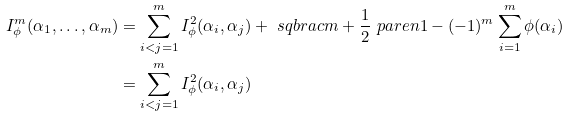<formula> <loc_0><loc_0><loc_500><loc_500>I _ { \phi } ^ { m } ( \alpha _ { 1 } , \dots , \alpha _ { m } ) & = \sum _ { i < j = 1 } ^ { m } I _ { \phi } ^ { 2 } ( \alpha _ { i } , \alpha _ { j } ) + \ s q b r a c { m + \frac { 1 } { 2 } \ p a r e n { 1 - ( - 1 ) ^ { m } } } \sum _ { i = 1 } ^ { m } \phi ( \alpha _ { i } ) \\ & = \sum _ { i < j = 1 } ^ { m } I _ { \phi } ^ { 2 } ( \alpha _ { i } , \alpha _ { j } )</formula> 